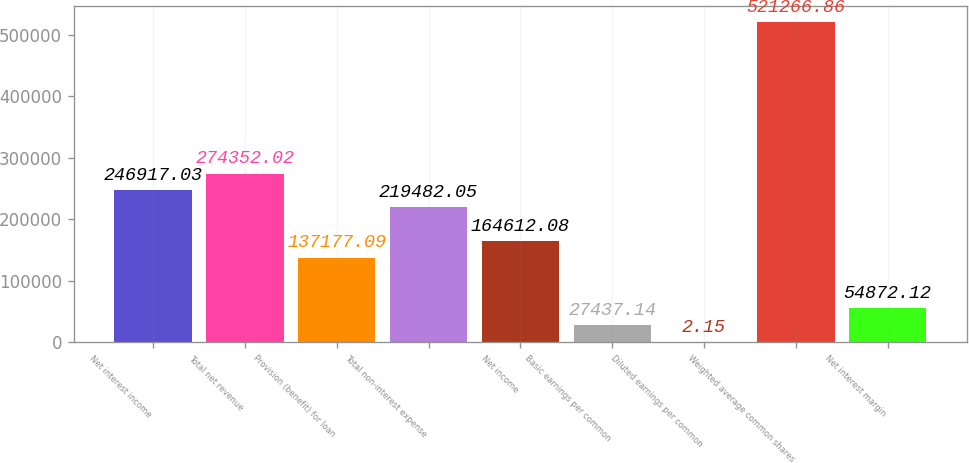Convert chart. <chart><loc_0><loc_0><loc_500><loc_500><bar_chart><fcel>Net interest income<fcel>Total net revenue<fcel>Provision (benefit) for loan<fcel>Total non-interest expense<fcel>Net income<fcel>Basic earnings per common<fcel>Diluted earnings per common<fcel>Weighted average common shares<fcel>Net interest margin<nl><fcel>246917<fcel>274352<fcel>137177<fcel>219482<fcel>164612<fcel>27437.1<fcel>2.15<fcel>521267<fcel>54872.1<nl></chart> 